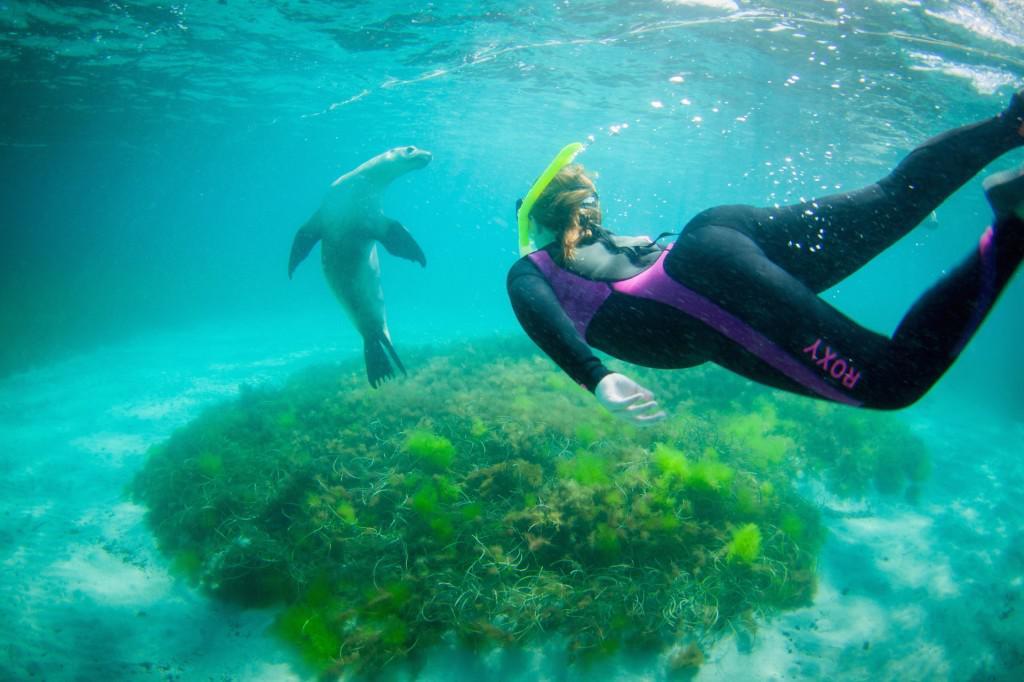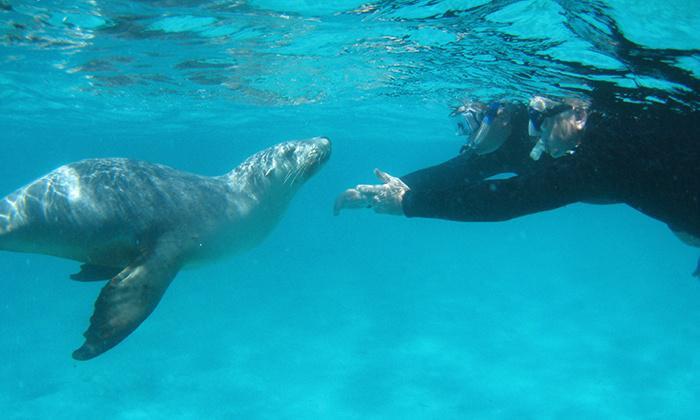The first image is the image on the left, the second image is the image on the right. For the images shown, is this caption "The left image shows a diver in a wetsuit interacting with a seal, but the right image does not include a diver." true? Answer yes or no. No. The first image is the image on the left, the second image is the image on the right. Assess this claim about the two images: "In at least one image there is a sea lion swimming alone with no other mammals present.". Correct or not? Answer yes or no. No. 